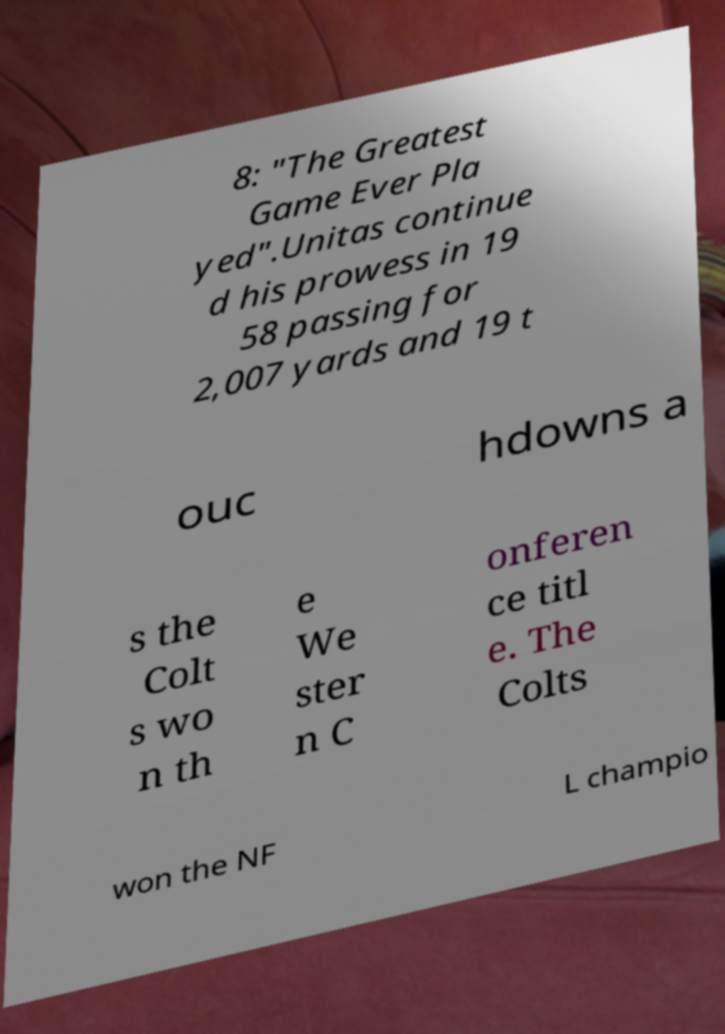There's text embedded in this image that I need extracted. Can you transcribe it verbatim? 8: "The Greatest Game Ever Pla yed".Unitas continue d his prowess in 19 58 passing for 2,007 yards and 19 t ouc hdowns a s the Colt s wo n th e We ster n C onferen ce titl e. The Colts won the NF L champio 